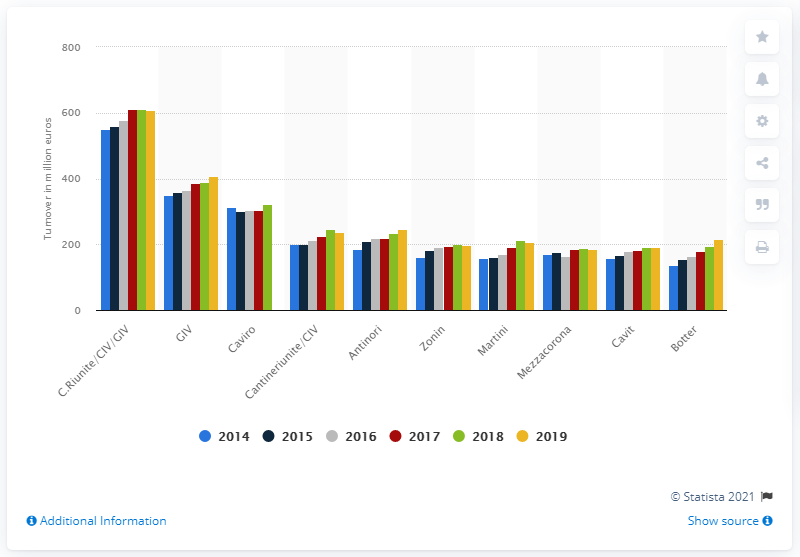Specify some key components in this picture. The leading Italian winery in 2019 was C.Riunite/CIV/GIV. 